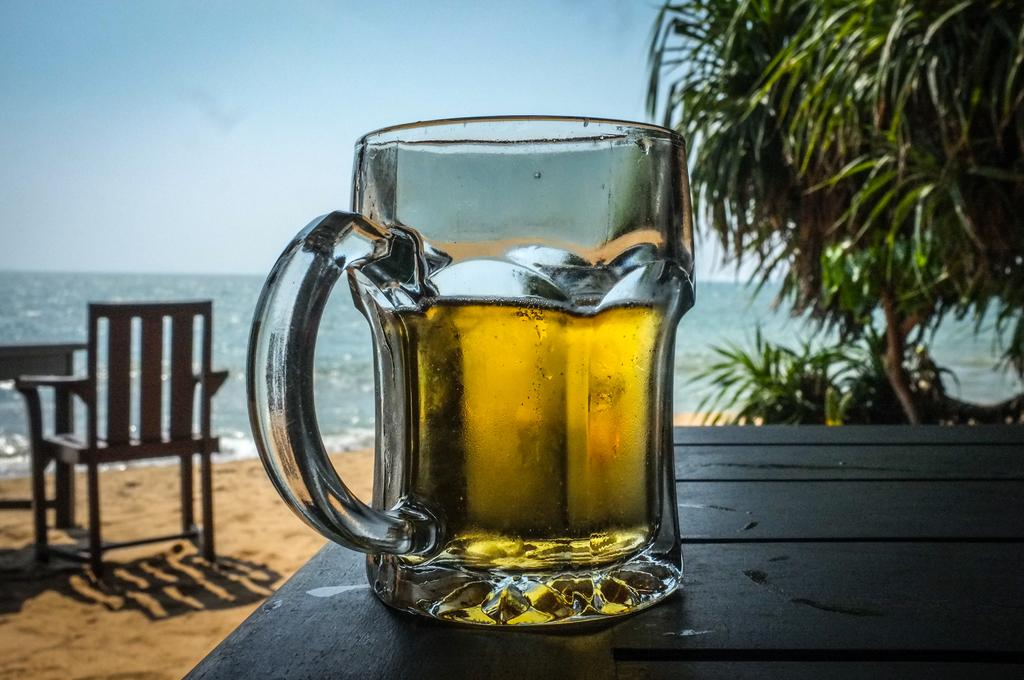What is on the table in the image? There is a glass on a table in the image. What can be seen in the background of the image? There is a chair, water, a tree, and the sky visible in the background. How many apples are hanging from the tree in the image? There is no apple present in the image, as it only shows a glass on a table and a tree in the background. Is there a rail visible in the image? There is no rail present in the image. 